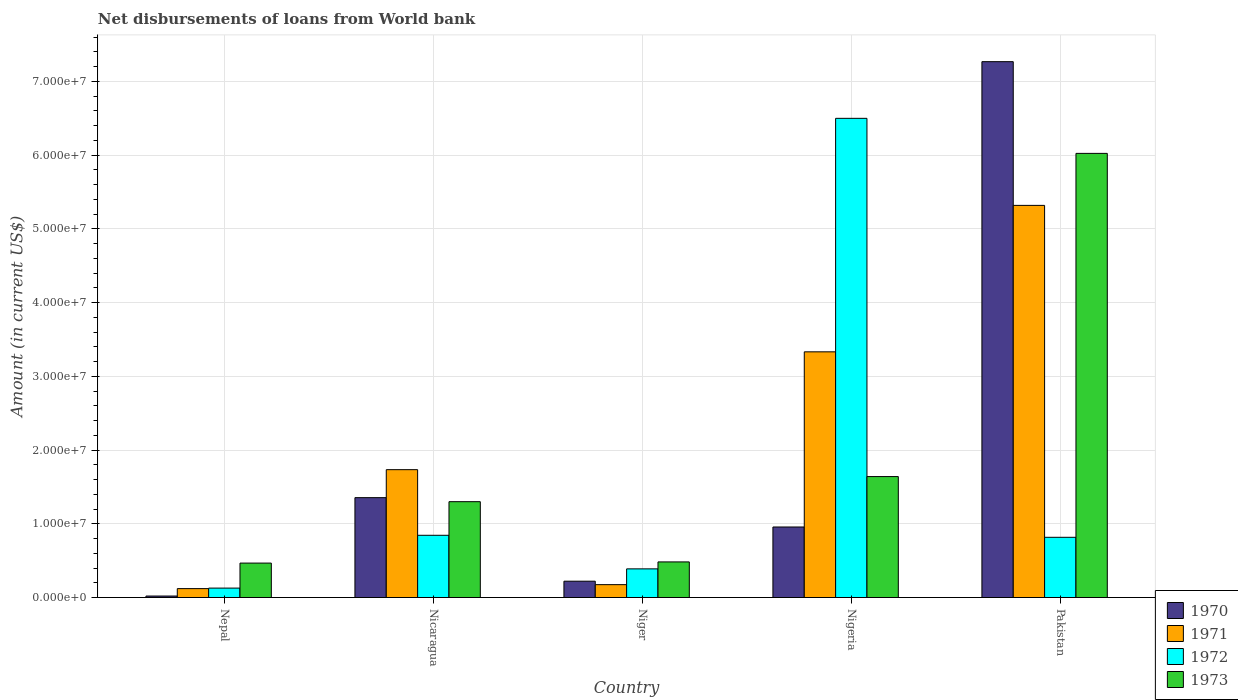How many groups of bars are there?
Offer a terse response. 5. Are the number of bars per tick equal to the number of legend labels?
Keep it short and to the point. Yes. Are the number of bars on each tick of the X-axis equal?
Provide a short and direct response. Yes. What is the label of the 1st group of bars from the left?
Offer a very short reply. Nepal. In how many cases, is the number of bars for a given country not equal to the number of legend labels?
Offer a terse response. 0. What is the amount of loan disbursed from World Bank in 1970 in Nepal?
Your answer should be very brief. 2.02e+05. Across all countries, what is the maximum amount of loan disbursed from World Bank in 1971?
Make the answer very short. 5.32e+07. Across all countries, what is the minimum amount of loan disbursed from World Bank in 1972?
Give a very brief answer. 1.28e+06. In which country was the amount of loan disbursed from World Bank in 1973 maximum?
Make the answer very short. Pakistan. In which country was the amount of loan disbursed from World Bank in 1973 minimum?
Provide a short and direct response. Nepal. What is the total amount of loan disbursed from World Bank in 1973 in the graph?
Give a very brief answer. 9.91e+07. What is the difference between the amount of loan disbursed from World Bank in 1971 in Niger and that in Pakistan?
Make the answer very short. -5.14e+07. What is the difference between the amount of loan disbursed from World Bank in 1972 in Nepal and the amount of loan disbursed from World Bank in 1973 in Pakistan?
Provide a short and direct response. -5.89e+07. What is the average amount of loan disbursed from World Bank in 1971 per country?
Your answer should be compact. 2.14e+07. What is the difference between the amount of loan disbursed from World Bank of/in 1973 and amount of loan disbursed from World Bank of/in 1970 in Pakistan?
Ensure brevity in your answer.  -1.24e+07. In how many countries, is the amount of loan disbursed from World Bank in 1970 greater than 58000000 US$?
Ensure brevity in your answer.  1. What is the ratio of the amount of loan disbursed from World Bank in 1970 in Nicaragua to that in Niger?
Provide a succinct answer. 6.11. What is the difference between the highest and the second highest amount of loan disbursed from World Bank in 1971?
Make the answer very short. 3.58e+07. What is the difference between the highest and the lowest amount of loan disbursed from World Bank in 1973?
Offer a very short reply. 5.56e+07. What does the 4th bar from the right in Niger represents?
Offer a terse response. 1970. Is it the case that in every country, the sum of the amount of loan disbursed from World Bank in 1972 and amount of loan disbursed from World Bank in 1970 is greater than the amount of loan disbursed from World Bank in 1971?
Provide a succinct answer. Yes. How many countries are there in the graph?
Your answer should be compact. 5. Are the values on the major ticks of Y-axis written in scientific E-notation?
Your answer should be compact. Yes. Does the graph contain any zero values?
Your response must be concise. No. Where does the legend appear in the graph?
Give a very brief answer. Bottom right. How many legend labels are there?
Keep it short and to the point. 4. What is the title of the graph?
Your answer should be very brief. Net disbursements of loans from World bank. What is the label or title of the X-axis?
Offer a very short reply. Country. What is the label or title of the Y-axis?
Keep it short and to the point. Amount (in current US$). What is the Amount (in current US$) in 1970 in Nepal?
Your response must be concise. 2.02e+05. What is the Amount (in current US$) in 1971 in Nepal?
Provide a succinct answer. 1.21e+06. What is the Amount (in current US$) of 1972 in Nepal?
Offer a terse response. 1.28e+06. What is the Amount (in current US$) in 1973 in Nepal?
Your response must be concise. 4.67e+06. What is the Amount (in current US$) in 1970 in Nicaragua?
Provide a succinct answer. 1.35e+07. What is the Amount (in current US$) in 1971 in Nicaragua?
Your answer should be compact. 1.73e+07. What is the Amount (in current US$) of 1972 in Nicaragua?
Make the answer very short. 8.44e+06. What is the Amount (in current US$) in 1973 in Nicaragua?
Ensure brevity in your answer.  1.30e+07. What is the Amount (in current US$) in 1970 in Niger?
Your response must be concise. 2.22e+06. What is the Amount (in current US$) of 1971 in Niger?
Ensure brevity in your answer.  1.75e+06. What is the Amount (in current US$) of 1972 in Niger?
Your answer should be very brief. 3.89e+06. What is the Amount (in current US$) in 1973 in Niger?
Give a very brief answer. 4.83e+06. What is the Amount (in current US$) of 1970 in Nigeria?
Make the answer very short. 9.56e+06. What is the Amount (in current US$) in 1971 in Nigeria?
Make the answer very short. 3.33e+07. What is the Amount (in current US$) in 1972 in Nigeria?
Give a very brief answer. 6.50e+07. What is the Amount (in current US$) of 1973 in Nigeria?
Provide a short and direct response. 1.64e+07. What is the Amount (in current US$) in 1970 in Pakistan?
Your answer should be very brief. 7.27e+07. What is the Amount (in current US$) of 1971 in Pakistan?
Provide a succinct answer. 5.32e+07. What is the Amount (in current US$) in 1972 in Pakistan?
Provide a short and direct response. 8.17e+06. What is the Amount (in current US$) in 1973 in Pakistan?
Your response must be concise. 6.02e+07. Across all countries, what is the maximum Amount (in current US$) of 1970?
Your answer should be very brief. 7.27e+07. Across all countries, what is the maximum Amount (in current US$) of 1971?
Give a very brief answer. 5.32e+07. Across all countries, what is the maximum Amount (in current US$) of 1972?
Offer a very short reply. 6.50e+07. Across all countries, what is the maximum Amount (in current US$) in 1973?
Make the answer very short. 6.02e+07. Across all countries, what is the minimum Amount (in current US$) in 1970?
Ensure brevity in your answer.  2.02e+05. Across all countries, what is the minimum Amount (in current US$) in 1971?
Offer a very short reply. 1.21e+06. Across all countries, what is the minimum Amount (in current US$) of 1972?
Provide a succinct answer. 1.28e+06. Across all countries, what is the minimum Amount (in current US$) of 1973?
Keep it short and to the point. 4.67e+06. What is the total Amount (in current US$) of 1970 in the graph?
Give a very brief answer. 9.82e+07. What is the total Amount (in current US$) in 1971 in the graph?
Offer a very short reply. 1.07e+08. What is the total Amount (in current US$) of 1972 in the graph?
Offer a terse response. 8.67e+07. What is the total Amount (in current US$) of 1973 in the graph?
Ensure brevity in your answer.  9.91e+07. What is the difference between the Amount (in current US$) of 1970 in Nepal and that in Nicaragua?
Your answer should be compact. -1.33e+07. What is the difference between the Amount (in current US$) of 1971 in Nepal and that in Nicaragua?
Provide a short and direct response. -1.61e+07. What is the difference between the Amount (in current US$) of 1972 in Nepal and that in Nicaragua?
Offer a terse response. -7.16e+06. What is the difference between the Amount (in current US$) in 1973 in Nepal and that in Nicaragua?
Offer a terse response. -8.33e+06. What is the difference between the Amount (in current US$) of 1970 in Nepal and that in Niger?
Provide a short and direct response. -2.01e+06. What is the difference between the Amount (in current US$) of 1971 in Nepal and that in Niger?
Offer a very short reply. -5.39e+05. What is the difference between the Amount (in current US$) of 1972 in Nepal and that in Niger?
Give a very brief answer. -2.61e+06. What is the difference between the Amount (in current US$) of 1973 in Nepal and that in Niger?
Your answer should be very brief. -1.59e+05. What is the difference between the Amount (in current US$) of 1970 in Nepal and that in Nigeria?
Your response must be concise. -9.36e+06. What is the difference between the Amount (in current US$) in 1971 in Nepal and that in Nigeria?
Keep it short and to the point. -3.21e+07. What is the difference between the Amount (in current US$) of 1972 in Nepal and that in Nigeria?
Offer a terse response. -6.37e+07. What is the difference between the Amount (in current US$) in 1973 in Nepal and that in Nigeria?
Offer a very short reply. -1.17e+07. What is the difference between the Amount (in current US$) of 1970 in Nepal and that in Pakistan?
Make the answer very short. -7.25e+07. What is the difference between the Amount (in current US$) of 1971 in Nepal and that in Pakistan?
Your response must be concise. -5.20e+07. What is the difference between the Amount (in current US$) of 1972 in Nepal and that in Pakistan?
Provide a succinct answer. -6.89e+06. What is the difference between the Amount (in current US$) of 1973 in Nepal and that in Pakistan?
Your response must be concise. -5.56e+07. What is the difference between the Amount (in current US$) in 1970 in Nicaragua and that in Niger?
Provide a succinct answer. 1.13e+07. What is the difference between the Amount (in current US$) of 1971 in Nicaragua and that in Niger?
Your response must be concise. 1.56e+07. What is the difference between the Amount (in current US$) in 1972 in Nicaragua and that in Niger?
Your answer should be compact. 4.55e+06. What is the difference between the Amount (in current US$) of 1973 in Nicaragua and that in Niger?
Ensure brevity in your answer.  8.17e+06. What is the difference between the Amount (in current US$) of 1970 in Nicaragua and that in Nigeria?
Your answer should be very brief. 3.98e+06. What is the difference between the Amount (in current US$) in 1971 in Nicaragua and that in Nigeria?
Provide a succinct answer. -1.60e+07. What is the difference between the Amount (in current US$) of 1972 in Nicaragua and that in Nigeria?
Keep it short and to the point. -5.65e+07. What is the difference between the Amount (in current US$) of 1973 in Nicaragua and that in Nigeria?
Your answer should be compact. -3.40e+06. What is the difference between the Amount (in current US$) of 1970 in Nicaragua and that in Pakistan?
Give a very brief answer. -5.91e+07. What is the difference between the Amount (in current US$) in 1971 in Nicaragua and that in Pakistan?
Your answer should be compact. -3.58e+07. What is the difference between the Amount (in current US$) of 1972 in Nicaragua and that in Pakistan?
Ensure brevity in your answer.  2.72e+05. What is the difference between the Amount (in current US$) in 1973 in Nicaragua and that in Pakistan?
Offer a terse response. -4.72e+07. What is the difference between the Amount (in current US$) in 1970 in Niger and that in Nigeria?
Ensure brevity in your answer.  -7.35e+06. What is the difference between the Amount (in current US$) of 1971 in Niger and that in Nigeria?
Your answer should be compact. -3.16e+07. What is the difference between the Amount (in current US$) of 1972 in Niger and that in Nigeria?
Ensure brevity in your answer.  -6.11e+07. What is the difference between the Amount (in current US$) in 1973 in Niger and that in Nigeria?
Your answer should be compact. -1.16e+07. What is the difference between the Amount (in current US$) of 1970 in Niger and that in Pakistan?
Your answer should be compact. -7.04e+07. What is the difference between the Amount (in current US$) in 1971 in Niger and that in Pakistan?
Give a very brief answer. -5.14e+07. What is the difference between the Amount (in current US$) of 1972 in Niger and that in Pakistan?
Make the answer very short. -4.28e+06. What is the difference between the Amount (in current US$) in 1973 in Niger and that in Pakistan?
Give a very brief answer. -5.54e+07. What is the difference between the Amount (in current US$) in 1970 in Nigeria and that in Pakistan?
Your answer should be very brief. -6.31e+07. What is the difference between the Amount (in current US$) in 1971 in Nigeria and that in Pakistan?
Offer a very short reply. -1.99e+07. What is the difference between the Amount (in current US$) of 1972 in Nigeria and that in Pakistan?
Your answer should be very brief. 5.68e+07. What is the difference between the Amount (in current US$) in 1973 in Nigeria and that in Pakistan?
Make the answer very short. -4.38e+07. What is the difference between the Amount (in current US$) of 1970 in Nepal and the Amount (in current US$) of 1971 in Nicaragua?
Offer a terse response. -1.71e+07. What is the difference between the Amount (in current US$) in 1970 in Nepal and the Amount (in current US$) in 1972 in Nicaragua?
Provide a short and direct response. -8.24e+06. What is the difference between the Amount (in current US$) in 1970 in Nepal and the Amount (in current US$) in 1973 in Nicaragua?
Give a very brief answer. -1.28e+07. What is the difference between the Amount (in current US$) of 1971 in Nepal and the Amount (in current US$) of 1972 in Nicaragua?
Give a very brief answer. -7.23e+06. What is the difference between the Amount (in current US$) in 1971 in Nepal and the Amount (in current US$) in 1973 in Nicaragua?
Make the answer very short. -1.18e+07. What is the difference between the Amount (in current US$) of 1972 in Nepal and the Amount (in current US$) of 1973 in Nicaragua?
Your answer should be very brief. -1.17e+07. What is the difference between the Amount (in current US$) in 1970 in Nepal and the Amount (in current US$) in 1971 in Niger?
Give a very brief answer. -1.54e+06. What is the difference between the Amount (in current US$) in 1970 in Nepal and the Amount (in current US$) in 1972 in Niger?
Provide a succinct answer. -3.68e+06. What is the difference between the Amount (in current US$) in 1970 in Nepal and the Amount (in current US$) in 1973 in Niger?
Your response must be concise. -4.63e+06. What is the difference between the Amount (in current US$) of 1971 in Nepal and the Amount (in current US$) of 1972 in Niger?
Make the answer very short. -2.68e+06. What is the difference between the Amount (in current US$) of 1971 in Nepal and the Amount (in current US$) of 1973 in Niger?
Make the answer very short. -3.62e+06. What is the difference between the Amount (in current US$) in 1972 in Nepal and the Amount (in current US$) in 1973 in Niger?
Give a very brief answer. -3.55e+06. What is the difference between the Amount (in current US$) in 1970 in Nepal and the Amount (in current US$) in 1971 in Nigeria?
Your response must be concise. -3.31e+07. What is the difference between the Amount (in current US$) of 1970 in Nepal and the Amount (in current US$) of 1972 in Nigeria?
Your response must be concise. -6.48e+07. What is the difference between the Amount (in current US$) of 1970 in Nepal and the Amount (in current US$) of 1973 in Nigeria?
Offer a very short reply. -1.62e+07. What is the difference between the Amount (in current US$) of 1971 in Nepal and the Amount (in current US$) of 1972 in Nigeria?
Your answer should be compact. -6.38e+07. What is the difference between the Amount (in current US$) in 1971 in Nepal and the Amount (in current US$) in 1973 in Nigeria?
Offer a very short reply. -1.52e+07. What is the difference between the Amount (in current US$) in 1972 in Nepal and the Amount (in current US$) in 1973 in Nigeria?
Offer a terse response. -1.51e+07. What is the difference between the Amount (in current US$) of 1970 in Nepal and the Amount (in current US$) of 1971 in Pakistan?
Make the answer very short. -5.30e+07. What is the difference between the Amount (in current US$) in 1970 in Nepal and the Amount (in current US$) in 1972 in Pakistan?
Make the answer very short. -7.96e+06. What is the difference between the Amount (in current US$) of 1970 in Nepal and the Amount (in current US$) of 1973 in Pakistan?
Offer a terse response. -6.00e+07. What is the difference between the Amount (in current US$) in 1971 in Nepal and the Amount (in current US$) in 1972 in Pakistan?
Your answer should be very brief. -6.96e+06. What is the difference between the Amount (in current US$) in 1971 in Nepal and the Amount (in current US$) in 1973 in Pakistan?
Offer a very short reply. -5.90e+07. What is the difference between the Amount (in current US$) of 1972 in Nepal and the Amount (in current US$) of 1973 in Pakistan?
Make the answer very short. -5.89e+07. What is the difference between the Amount (in current US$) of 1970 in Nicaragua and the Amount (in current US$) of 1971 in Niger?
Your answer should be very brief. 1.18e+07. What is the difference between the Amount (in current US$) of 1970 in Nicaragua and the Amount (in current US$) of 1972 in Niger?
Make the answer very short. 9.66e+06. What is the difference between the Amount (in current US$) in 1970 in Nicaragua and the Amount (in current US$) in 1973 in Niger?
Your answer should be compact. 8.71e+06. What is the difference between the Amount (in current US$) in 1971 in Nicaragua and the Amount (in current US$) in 1972 in Niger?
Offer a terse response. 1.35e+07. What is the difference between the Amount (in current US$) of 1971 in Nicaragua and the Amount (in current US$) of 1973 in Niger?
Your response must be concise. 1.25e+07. What is the difference between the Amount (in current US$) of 1972 in Nicaragua and the Amount (in current US$) of 1973 in Niger?
Offer a terse response. 3.61e+06. What is the difference between the Amount (in current US$) of 1970 in Nicaragua and the Amount (in current US$) of 1971 in Nigeria?
Provide a succinct answer. -1.98e+07. What is the difference between the Amount (in current US$) in 1970 in Nicaragua and the Amount (in current US$) in 1972 in Nigeria?
Give a very brief answer. -5.14e+07. What is the difference between the Amount (in current US$) of 1970 in Nicaragua and the Amount (in current US$) of 1973 in Nigeria?
Your answer should be very brief. -2.86e+06. What is the difference between the Amount (in current US$) in 1971 in Nicaragua and the Amount (in current US$) in 1972 in Nigeria?
Your response must be concise. -4.76e+07. What is the difference between the Amount (in current US$) in 1971 in Nicaragua and the Amount (in current US$) in 1973 in Nigeria?
Your answer should be compact. 9.37e+05. What is the difference between the Amount (in current US$) of 1972 in Nicaragua and the Amount (in current US$) of 1973 in Nigeria?
Ensure brevity in your answer.  -7.96e+06. What is the difference between the Amount (in current US$) of 1970 in Nicaragua and the Amount (in current US$) of 1971 in Pakistan?
Your answer should be compact. -3.96e+07. What is the difference between the Amount (in current US$) of 1970 in Nicaragua and the Amount (in current US$) of 1972 in Pakistan?
Give a very brief answer. 5.38e+06. What is the difference between the Amount (in current US$) of 1970 in Nicaragua and the Amount (in current US$) of 1973 in Pakistan?
Provide a succinct answer. -4.67e+07. What is the difference between the Amount (in current US$) in 1971 in Nicaragua and the Amount (in current US$) in 1972 in Pakistan?
Provide a succinct answer. 9.17e+06. What is the difference between the Amount (in current US$) of 1971 in Nicaragua and the Amount (in current US$) of 1973 in Pakistan?
Make the answer very short. -4.29e+07. What is the difference between the Amount (in current US$) of 1972 in Nicaragua and the Amount (in current US$) of 1973 in Pakistan?
Give a very brief answer. -5.18e+07. What is the difference between the Amount (in current US$) in 1970 in Niger and the Amount (in current US$) in 1971 in Nigeria?
Your answer should be very brief. -3.11e+07. What is the difference between the Amount (in current US$) in 1970 in Niger and the Amount (in current US$) in 1972 in Nigeria?
Your answer should be very brief. -6.28e+07. What is the difference between the Amount (in current US$) of 1970 in Niger and the Amount (in current US$) of 1973 in Nigeria?
Offer a terse response. -1.42e+07. What is the difference between the Amount (in current US$) in 1971 in Niger and the Amount (in current US$) in 1972 in Nigeria?
Offer a very short reply. -6.32e+07. What is the difference between the Amount (in current US$) in 1971 in Niger and the Amount (in current US$) in 1973 in Nigeria?
Ensure brevity in your answer.  -1.47e+07. What is the difference between the Amount (in current US$) in 1972 in Niger and the Amount (in current US$) in 1973 in Nigeria?
Keep it short and to the point. -1.25e+07. What is the difference between the Amount (in current US$) of 1970 in Niger and the Amount (in current US$) of 1971 in Pakistan?
Your response must be concise. -5.10e+07. What is the difference between the Amount (in current US$) of 1970 in Niger and the Amount (in current US$) of 1972 in Pakistan?
Your response must be concise. -5.95e+06. What is the difference between the Amount (in current US$) in 1970 in Niger and the Amount (in current US$) in 1973 in Pakistan?
Provide a succinct answer. -5.80e+07. What is the difference between the Amount (in current US$) in 1971 in Niger and the Amount (in current US$) in 1972 in Pakistan?
Offer a terse response. -6.42e+06. What is the difference between the Amount (in current US$) in 1971 in Niger and the Amount (in current US$) in 1973 in Pakistan?
Your response must be concise. -5.85e+07. What is the difference between the Amount (in current US$) in 1972 in Niger and the Amount (in current US$) in 1973 in Pakistan?
Give a very brief answer. -5.63e+07. What is the difference between the Amount (in current US$) in 1970 in Nigeria and the Amount (in current US$) in 1971 in Pakistan?
Provide a succinct answer. -4.36e+07. What is the difference between the Amount (in current US$) in 1970 in Nigeria and the Amount (in current US$) in 1972 in Pakistan?
Provide a succinct answer. 1.40e+06. What is the difference between the Amount (in current US$) of 1970 in Nigeria and the Amount (in current US$) of 1973 in Pakistan?
Ensure brevity in your answer.  -5.07e+07. What is the difference between the Amount (in current US$) of 1971 in Nigeria and the Amount (in current US$) of 1972 in Pakistan?
Provide a succinct answer. 2.51e+07. What is the difference between the Amount (in current US$) of 1971 in Nigeria and the Amount (in current US$) of 1973 in Pakistan?
Your answer should be very brief. -2.69e+07. What is the difference between the Amount (in current US$) of 1972 in Nigeria and the Amount (in current US$) of 1973 in Pakistan?
Keep it short and to the point. 4.75e+06. What is the average Amount (in current US$) of 1970 per country?
Give a very brief answer. 1.96e+07. What is the average Amount (in current US$) in 1971 per country?
Provide a short and direct response. 2.14e+07. What is the average Amount (in current US$) of 1972 per country?
Make the answer very short. 1.73e+07. What is the average Amount (in current US$) of 1973 per country?
Offer a very short reply. 1.98e+07. What is the difference between the Amount (in current US$) of 1970 and Amount (in current US$) of 1971 in Nepal?
Provide a succinct answer. -1.00e+06. What is the difference between the Amount (in current US$) of 1970 and Amount (in current US$) of 1972 in Nepal?
Your answer should be compact. -1.08e+06. What is the difference between the Amount (in current US$) in 1970 and Amount (in current US$) in 1973 in Nepal?
Make the answer very short. -4.47e+06. What is the difference between the Amount (in current US$) of 1971 and Amount (in current US$) of 1972 in Nepal?
Provide a short and direct response. -7.00e+04. What is the difference between the Amount (in current US$) in 1971 and Amount (in current US$) in 1973 in Nepal?
Offer a very short reply. -3.46e+06. What is the difference between the Amount (in current US$) in 1972 and Amount (in current US$) in 1973 in Nepal?
Provide a short and direct response. -3.39e+06. What is the difference between the Amount (in current US$) of 1970 and Amount (in current US$) of 1971 in Nicaragua?
Make the answer very short. -3.80e+06. What is the difference between the Amount (in current US$) of 1970 and Amount (in current US$) of 1972 in Nicaragua?
Offer a terse response. 5.10e+06. What is the difference between the Amount (in current US$) in 1970 and Amount (in current US$) in 1973 in Nicaragua?
Offer a very short reply. 5.46e+05. What is the difference between the Amount (in current US$) in 1971 and Amount (in current US$) in 1972 in Nicaragua?
Make the answer very short. 8.90e+06. What is the difference between the Amount (in current US$) in 1971 and Amount (in current US$) in 1973 in Nicaragua?
Offer a very short reply. 4.34e+06. What is the difference between the Amount (in current US$) of 1972 and Amount (in current US$) of 1973 in Nicaragua?
Give a very brief answer. -4.56e+06. What is the difference between the Amount (in current US$) in 1970 and Amount (in current US$) in 1971 in Niger?
Provide a succinct answer. 4.69e+05. What is the difference between the Amount (in current US$) of 1970 and Amount (in current US$) of 1972 in Niger?
Offer a terse response. -1.67e+06. What is the difference between the Amount (in current US$) of 1970 and Amount (in current US$) of 1973 in Niger?
Provide a succinct answer. -2.61e+06. What is the difference between the Amount (in current US$) in 1971 and Amount (in current US$) in 1972 in Niger?
Provide a succinct answer. -2.14e+06. What is the difference between the Amount (in current US$) in 1971 and Amount (in current US$) in 1973 in Niger?
Keep it short and to the point. -3.08e+06. What is the difference between the Amount (in current US$) of 1972 and Amount (in current US$) of 1973 in Niger?
Your answer should be compact. -9.42e+05. What is the difference between the Amount (in current US$) in 1970 and Amount (in current US$) in 1971 in Nigeria?
Offer a very short reply. -2.38e+07. What is the difference between the Amount (in current US$) of 1970 and Amount (in current US$) of 1972 in Nigeria?
Keep it short and to the point. -5.54e+07. What is the difference between the Amount (in current US$) in 1970 and Amount (in current US$) in 1973 in Nigeria?
Your response must be concise. -6.84e+06. What is the difference between the Amount (in current US$) in 1971 and Amount (in current US$) in 1972 in Nigeria?
Provide a short and direct response. -3.17e+07. What is the difference between the Amount (in current US$) of 1971 and Amount (in current US$) of 1973 in Nigeria?
Provide a short and direct response. 1.69e+07. What is the difference between the Amount (in current US$) in 1972 and Amount (in current US$) in 1973 in Nigeria?
Offer a terse response. 4.86e+07. What is the difference between the Amount (in current US$) of 1970 and Amount (in current US$) of 1971 in Pakistan?
Keep it short and to the point. 1.95e+07. What is the difference between the Amount (in current US$) in 1970 and Amount (in current US$) in 1972 in Pakistan?
Make the answer very short. 6.45e+07. What is the difference between the Amount (in current US$) of 1970 and Amount (in current US$) of 1973 in Pakistan?
Give a very brief answer. 1.24e+07. What is the difference between the Amount (in current US$) in 1971 and Amount (in current US$) in 1972 in Pakistan?
Ensure brevity in your answer.  4.50e+07. What is the difference between the Amount (in current US$) in 1971 and Amount (in current US$) in 1973 in Pakistan?
Ensure brevity in your answer.  -7.05e+06. What is the difference between the Amount (in current US$) in 1972 and Amount (in current US$) in 1973 in Pakistan?
Ensure brevity in your answer.  -5.21e+07. What is the ratio of the Amount (in current US$) in 1970 in Nepal to that in Nicaragua?
Offer a terse response. 0.01. What is the ratio of the Amount (in current US$) of 1971 in Nepal to that in Nicaragua?
Your answer should be very brief. 0.07. What is the ratio of the Amount (in current US$) of 1972 in Nepal to that in Nicaragua?
Provide a succinct answer. 0.15. What is the ratio of the Amount (in current US$) in 1973 in Nepal to that in Nicaragua?
Offer a very short reply. 0.36. What is the ratio of the Amount (in current US$) in 1970 in Nepal to that in Niger?
Ensure brevity in your answer.  0.09. What is the ratio of the Amount (in current US$) in 1971 in Nepal to that in Niger?
Give a very brief answer. 0.69. What is the ratio of the Amount (in current US$) in 1972 in Nepal to that in Niger?
Provide a succinct answer. 0.33. What is the ratio of the Amount (in current US$) of 1973 in Nepal to that in Niger?
Make the answer very short. 0.97. What is the ratio of the Amount (in current US$) of 1970 in Nepal to that in Nigeria?
Your answer should be compact. 0.02. What is the ratio of the Amount (in current US$) in 1971 in Nepal to that in Nigeria?
Ensure brevity in your answer.  0.04. What is the ratio of the Amount (in current US$) of 1972 in Nepal to that in Nigeria?
Your response must be concise. 0.02. What is the ratio of the Amount (in current US$) in 1973 in Nepal to that in Nigeria?
Ensure brevity in your answer.  0.28. What is the ratio of the Amount (in current US$) in 1970 in Nepal to that in Pakistan?
Give a very brief answer. 0. What is the ratio of the Amount (in current US$) of 1971 in Nepal to that in Pakistan?
Provide a succinct answer. 0.02. What is the ratio of the Amount (in current US$) in 1972 in Nepal to that in Pakistan?
Provide a short and direct response. 0.16. What is the ratio of the Amount (in current US$) in 1973 in Nepal to that in Pakistan?
Offer a very short reply. 0.08. What is the ratio of the Amount (in current US$) of 1970 in Nicaragua to that in Niger?
Ensure brevity in your answer.  6.11. What is the ratio of the Amount (in current US$) in 1971 in Nicaragua to that in Niger?
Offer a terse response. 9.93. What is the ratio of the Amount (in current US$) of 1972 in Nicaragua to that in Niger?
Your answer should be very brief. 2.17. What is the ratio of the Amount (in current US$) in 1973 in Nicaragua to that in Niger?
Provide a short and direct response. 2.69. What is the ratio of the Amount (in current US$) in 1970 in Nicaragua to that in Nigeria?
Give a very brief answer. 1.42. What is the ratio of the Amount (in current US$) in 1971 in Nicaragua to that in Nigeria?
Ensure brevity in your answer.  0.52. What is the ratio of the Amount (in current US$) of 1972 in Nicaragua to that in Nigeria?
Your answer should be very brief. 0.13. What is the ratio of the Amount (in current US$) of 1973 in Nicaragua to that in Nigeria?
Your answer should be compact. 0.79. What is the ratio of the Amount (in current US$) in 1970 in Nicaragua to that in Pakistan?
Provide a succinct answer. 0.19. What is the ratio of the Amount (in current US$) in 1971 in Nicaragua to that in Pakistan?
Give a very brief answer. 0.33. What is the ratio of the Amount (in current US$) of 1973 in Nicaragua to that in Pakistan?
Offer a terse response. 0.22. What is the ratio of the Amount (in current US$) of 1970 in Niger to that in Nigeria?
Offer a terse response. 0.23. What is the ratio of the Amount (in current US$) of 1971 in Niger to that in Nigeria?
Make the answer very short. 0.05. What is the ratio of the Amount (in current US$) of 1972 in Niger to that in Nigeria?
Give a very brief answer. 0.06. What is the ratio of the Amount (in current US$) in 1973 in Niger to that in Nigeria?
Your answer should be compact. 0.29. What is the ratio of the Amount (in current US$) of 1970 in Niger to that in Pakistan?
Offer a very short reply. 0.03. What is the ratio of the Amount (in current US$) of 1971 in Niger to that in Pakistan?
Offer a very short reply. 0.03. What is the ratio of the Amount (in current US$) in 1972 in Niger to that in Pakistan?
Provide a short and direct response. 0.48. What is the ratio of the Amount (in current US$) in 1973 in Niger to that in Pakistan?
Your response must be concise. 0.08. What is the ratio of the Amount (in current US$) in 1970 in Nigeria to that in Pakistan?
Keep it short and to the point. 0.13. What is the ratio of the Amount (in current US$) of 1971 in Nigeria to that in Pakistan?
Offer a very short reply. 0.63. What is the ratio of the Amount (in current US$) in 1972 in Nigeria to that in Pakistan?
Your response must be concise. 7.96. What is the ratio of the Amount (in current US$) in 1973 in Nigeria to that in Pakistan?
Ensure brevity in your answer.  0.27. What is the difference between the highest and the second highest Amount (in current US$) in 1970?
Provide a short and direct response. 5.91e+07. What is the difference between the highest and the second highest Amount (in current US$) of 1971?
Provide a short and direct response. 1.99e+07. What is the difference between the highest and the second highest Amount (in current US$) of 1972?
Offer a very short reply. 5.65e+07. What is the difference between the highest and the second highest Amount (in current US$) of 1973?
Provide a short and direct response. 4.38e+07. What is the difference between the highest and the lowest Amount (in current US$) in 1970?
Make the answer very short. 7.25e+07. What is the difference between the highest and the lowest Amount (in current US$) of 1971?
Keep it short and to the point. 5.20e+07. What is the difference between the highest and the lowest Amount (in current US$) in 1972?
Your answer should be very brief. 6.37e+07. What is the difference between the highest and the lowest Amount (in current US$) of 1973?
Ensure brevity in your answer.  5.56e+07. 